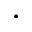<formula> <loc_0><loc_0><loc_500><loc_500>.</formula> 